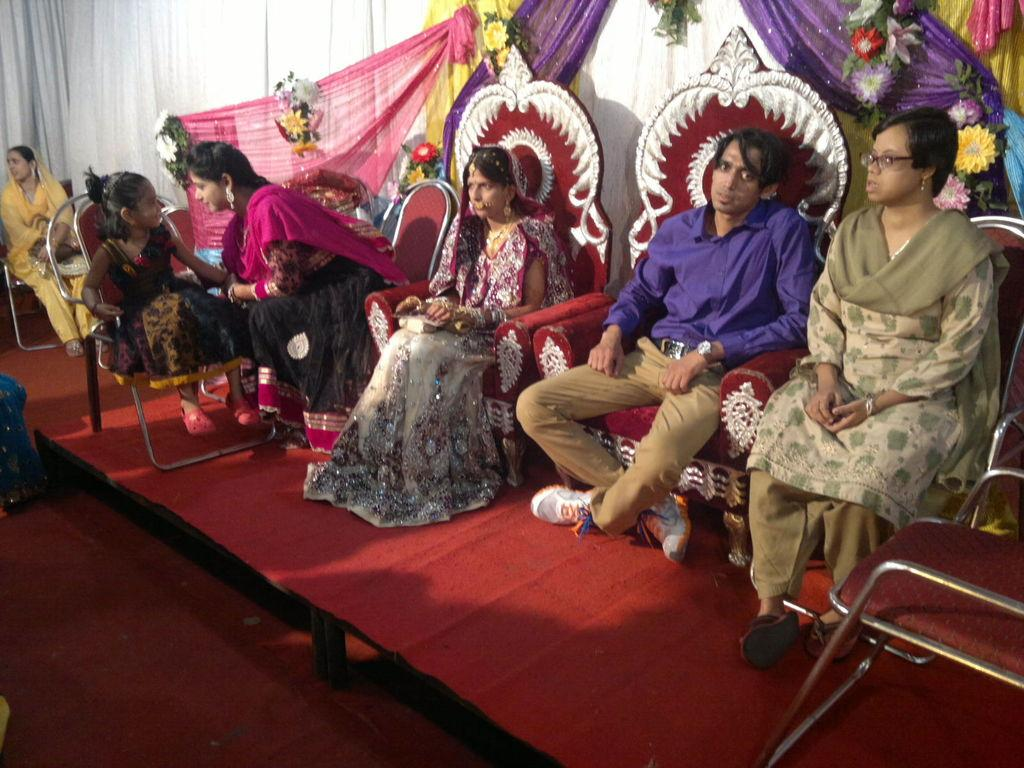What are the people in the image doing? The people in the image are sitting on chairs. What can be seen in the background of the image? There is decoration with flowers and curtains in the background of the image. What account number is associated with the flowers in the image? There is no account number associated with the flowers in the image, as they are a decorative element and not a financial entity. 